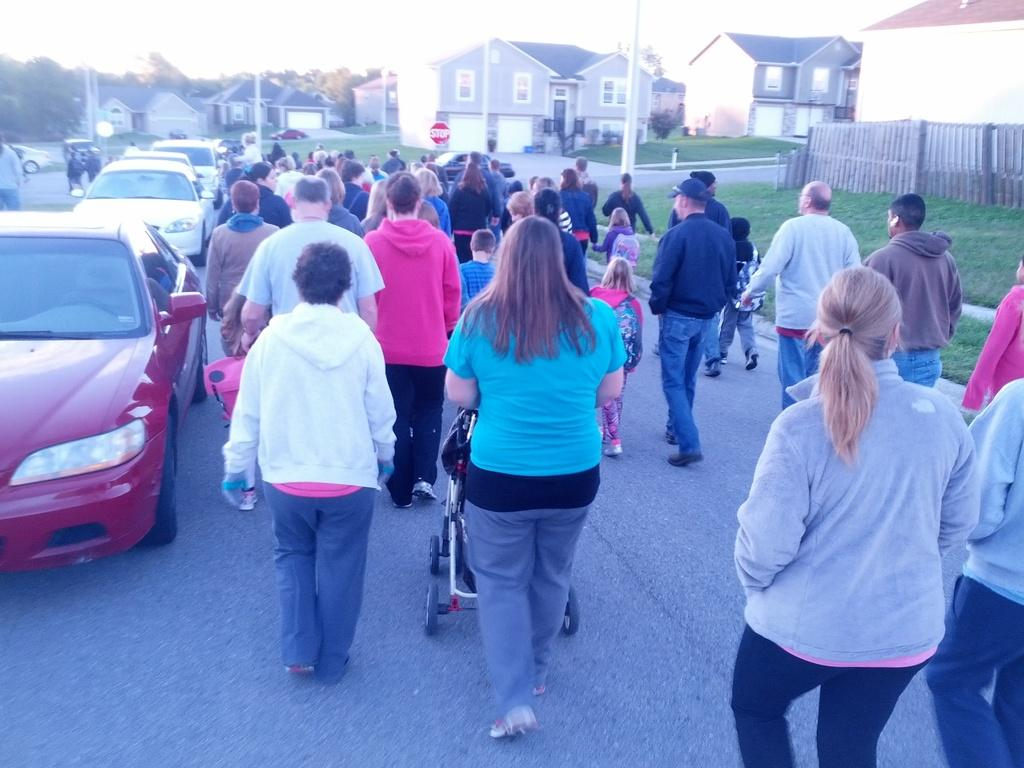What are the people in the image doing? There are people walking on the road in the image. What else can be seen on the road in the image? There are vehicles on the left side of the road in the image. What is visible around the road in the image? There are houses and trees around the road in the image. What type of trade is happening between the people and the sand in the image? There is no sand present in the image, and therefore no trade can be observed. 